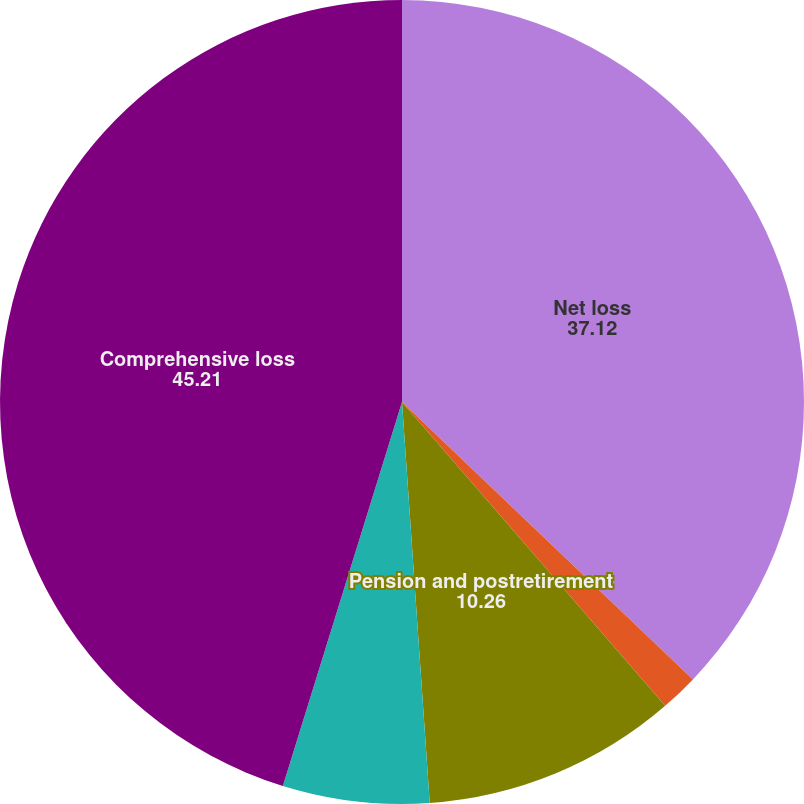Convert chart. <chart><loc_0><loc_0><loc_500><loc_500><pie_chart><fcel>Net loss<fcel>Currency translation<fcel>Pension and postretirement<fcel>Net unrealized gains on<fcel>Comprehensive loss<nl><fcel>37.12%<fcel>1.52%<fcel>10.26%<fcel>5.89%<fcel>45.21%<nl></chart> 